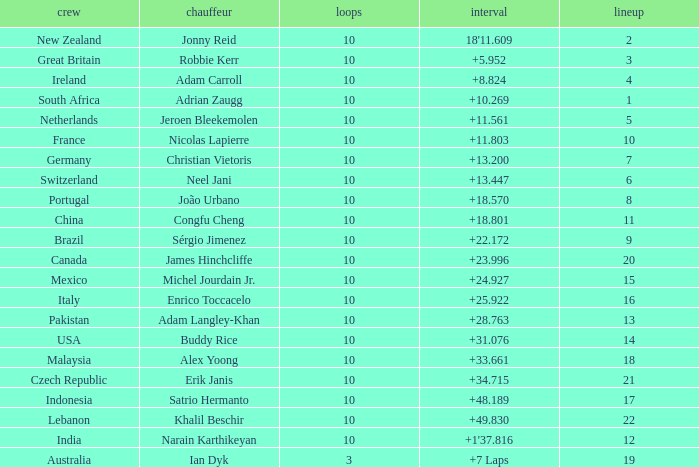For what Team is Narain Karthikeyan the Driver? India. 